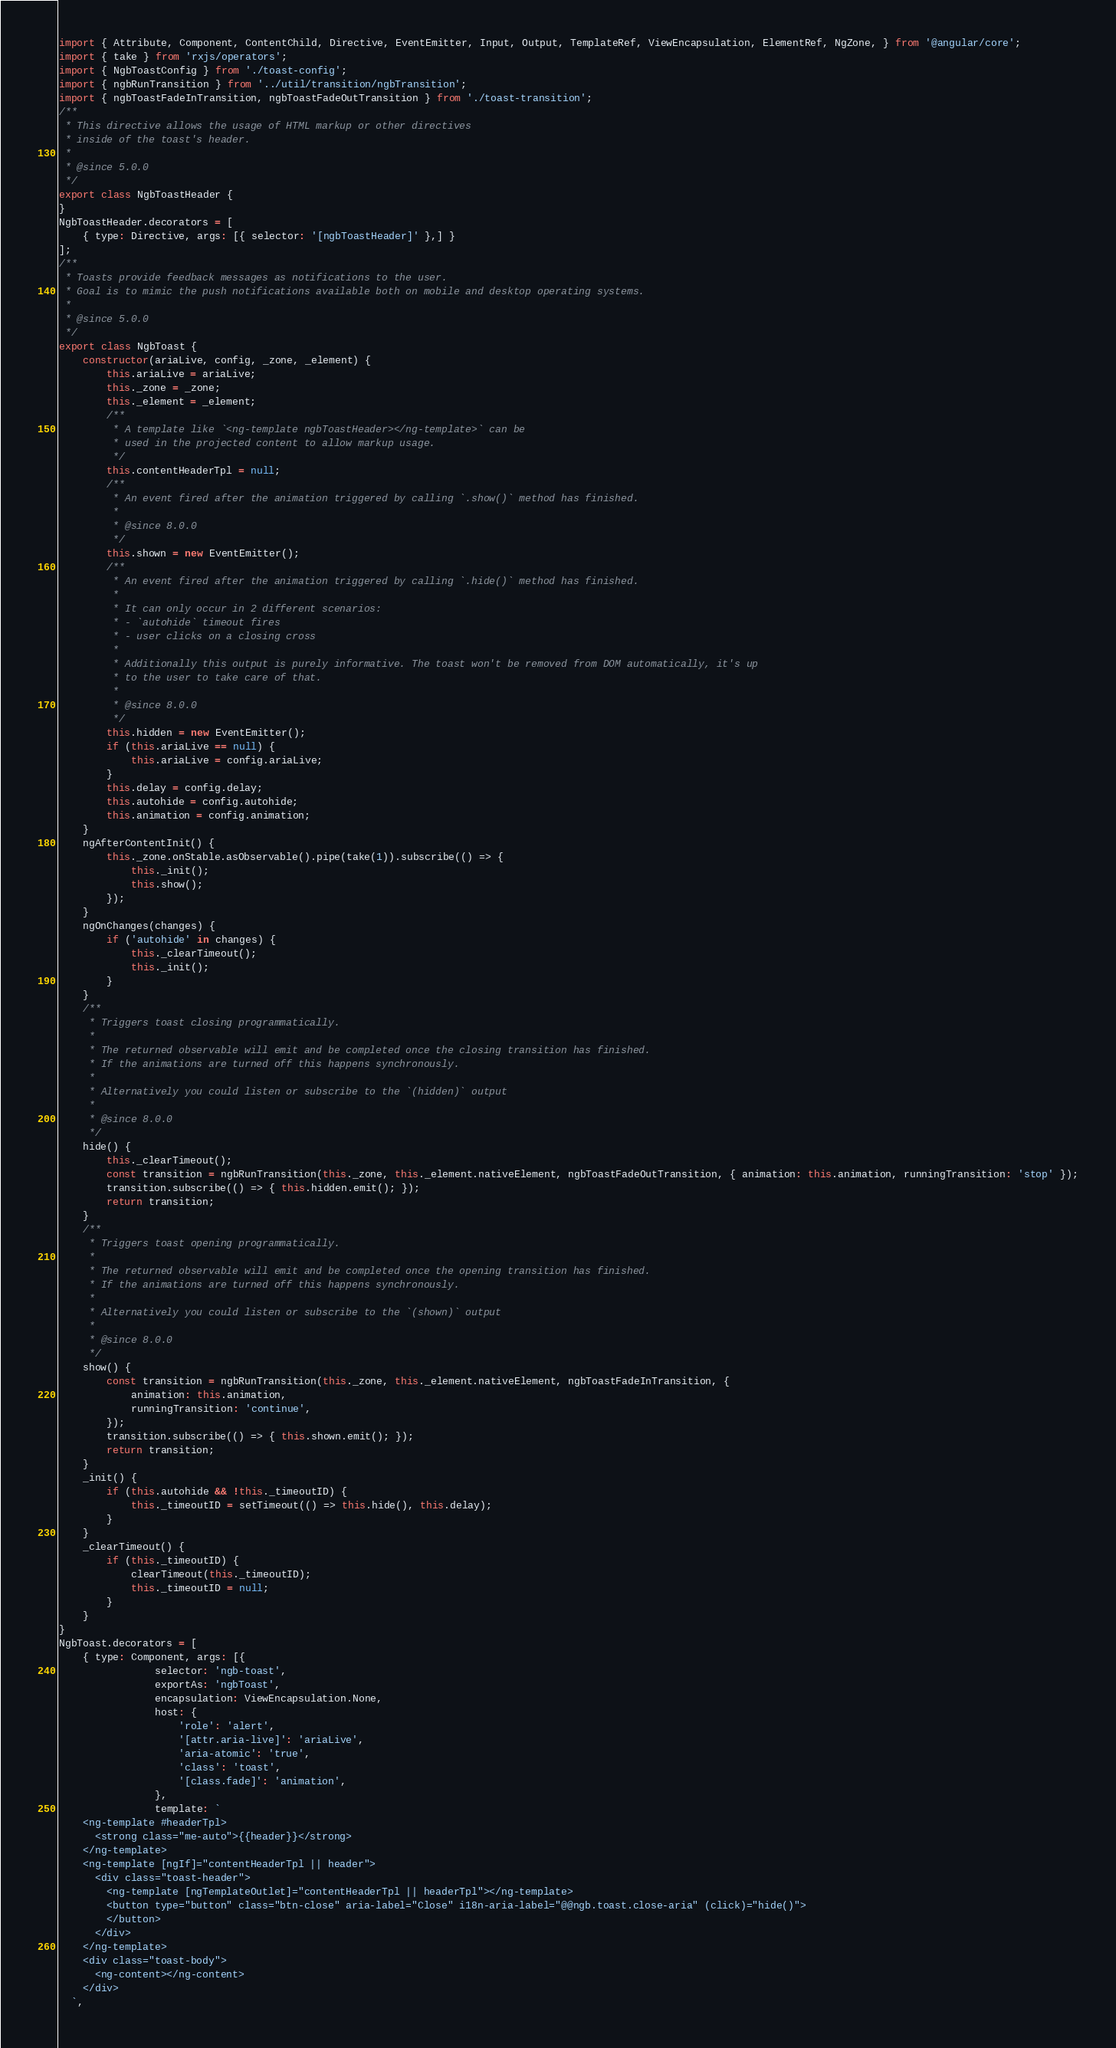Convert code to text. <code><loc_0><loc_0><loc_500><loc_500><_JavaScript_>import { Attribute, Component, ContentChild, Directive, EventEmitter, Input, Output, TemplateRef, ViewEncapsulation, ElementRef, NgZone, } from '@angular/core';
import { take } from 'rxjs/operators';
import { NgbToastConfig } from './toast-config';
import { ngbRunTransition } from '../util/transition/ngbTransition';
import { ngbToastFadeInTransition, ngbToastFadeOutTransition } from './toast-transition';
/**
 * This directive allows the usage of HTML markup or other directives
 * inside of the toast's header.
 *
 * @since 5.0.0
 */
export class NgbToastHeader {
}
NgbToastHeader.decorators = [
    { type: Directive, args: [{ selector: '[ngbToastHeader]' },] }
];
/**
 * Toasts provide feedback messages as notifications to the user.
 * Goal is to mimic the push notifications available both on mobile and desktop operating systems.
 *
 * @since 5.0.0
 */
export class NgbToast {
    constructor(ariaLive, config, _zone, _element) {
        this.ariaLive = ariaLive;
        this._zone = _zone;
        this._element = _element;
        /**
         * A template like `<ng-template ngbToastHeader></ng-template>` can be
         * used in the projected content to allow markup usage.
         */
        this.contentHeaderTpl = null;
        /**
         * An event fired after the animation triggered by calling `.show()` method has finished.
         *
         * @since 8.0.0
         */
        this.shown = new EventEmitter();
        /**
         * An event fired after the animation triggered by calling `.hide()` method has finished.
         *
         * It can only occur in 2 different scenarios:
         * - `autohide` timeout fires
         * - user clicks on a closing cross
         *
         * Additionally this output is purely informative. The toast won't be removed from DOM automatically, it's up
         * to the user to take care of that.
         *
         * @since 8.0.0
         */
        this.hidden = new EventEmitter();
        if (this.ariaLive == null) {
            this.ariaLive = config.ariaLive;
        }
        this.delay = config.delay;
        this.autohide = config.autohide;
        this.animation = config.animation;
    }
    ngAfterContentInit() {
        this._zone.onStable.asObservable().pipe(take(1)).subscribe(() => {
            this._init();
            this.show();
        });
    }
    ngOnChanges(changes) {
        if ('autohide' in changes) {
            this._clearTimeout();
            this._init();
        }
    }
    /**
     * Triggers toast closing programmatically.
     *
     * The returned observable will emit and be completed once the closing transition has finished.
     * If the animations are turned off this happens synchronously.
     *
     * Alternatively you could listen or subscribe to the `(hidden)` output
     *
     * @since 8.0.0
     */
    hide() {
        this._clearTimeout();
        const transition = ngbRunTransition(this._zone, this._element.nativeElement, ngbToastFadeOutTransition, { animation: this.animation, runningTransition: 'stop' });
        transition.subscribe(() => { this.hidden.emit(); });
        return transition;
    }
    /**
     * Triggers toast opening programmatically.
     *
     * The returned observable will emit and be completed once the opening transition has finished.
     * If the animations are turned off this happens synchronously.
     *
     * Alternatively you could listen or subscribe to the `(shown)` output
     *
     * @since 8.0.0
     */
    show() {
        const transition = ngbRunTransition(this._zone, this._element.nativeElement, ngbToastFadeInTransition, {
            animation: this.animation,
            runningTransition: 'continue',
        });
        transition.subscribe(() => { this.shown.emit(); });
        return transition;
    }
    _init() {
        if (this.autohide && !this._timeoutID) {
            this._timeoutID = setTimeout(() => this.hide(), this.delay);
        }
    }
    _clearTimeout() {
        if (this._timeoutID) {
            clearTimeout(this._timeoutID);
            this._timeoutID = null;
        }
    }
}
NgbToast.decorators = [
    { type: Component, args: [{
                selector: 'ngb-toast',
                exportAs: 'ngbToast',
                encapsulation: ViewEncapsulation.None,
                host: {
                    'role': 'alert',
                    '[attr.aria-live]': 'ariaLive',
                    'aria-atomic': 'true',
                    'class': 'toast',
                    '[class.fade]': 'animation',
                },
                template: `
    <ng-template #headerTpl>
      <strong class="me-auto">{{header}}</strong>
    </ng-template>
    <ng-template [ngIf]="contentHeaderTpl || header">
      <div class="toast-header">
        <ng-template [ngTemplateOutlet]="contentHeaderTpl || headerTpl"></ng-template>
        <button type="button" class="btn-close" aria-label="Close" i18n-aria-label="@@ngb.toast.close-aria" (click)="hide()">
        </button>
      </div>
    </ng-template>
    <div class="toast-body">
      <ng-content></ng-content>
    </div>
  `,</code> 